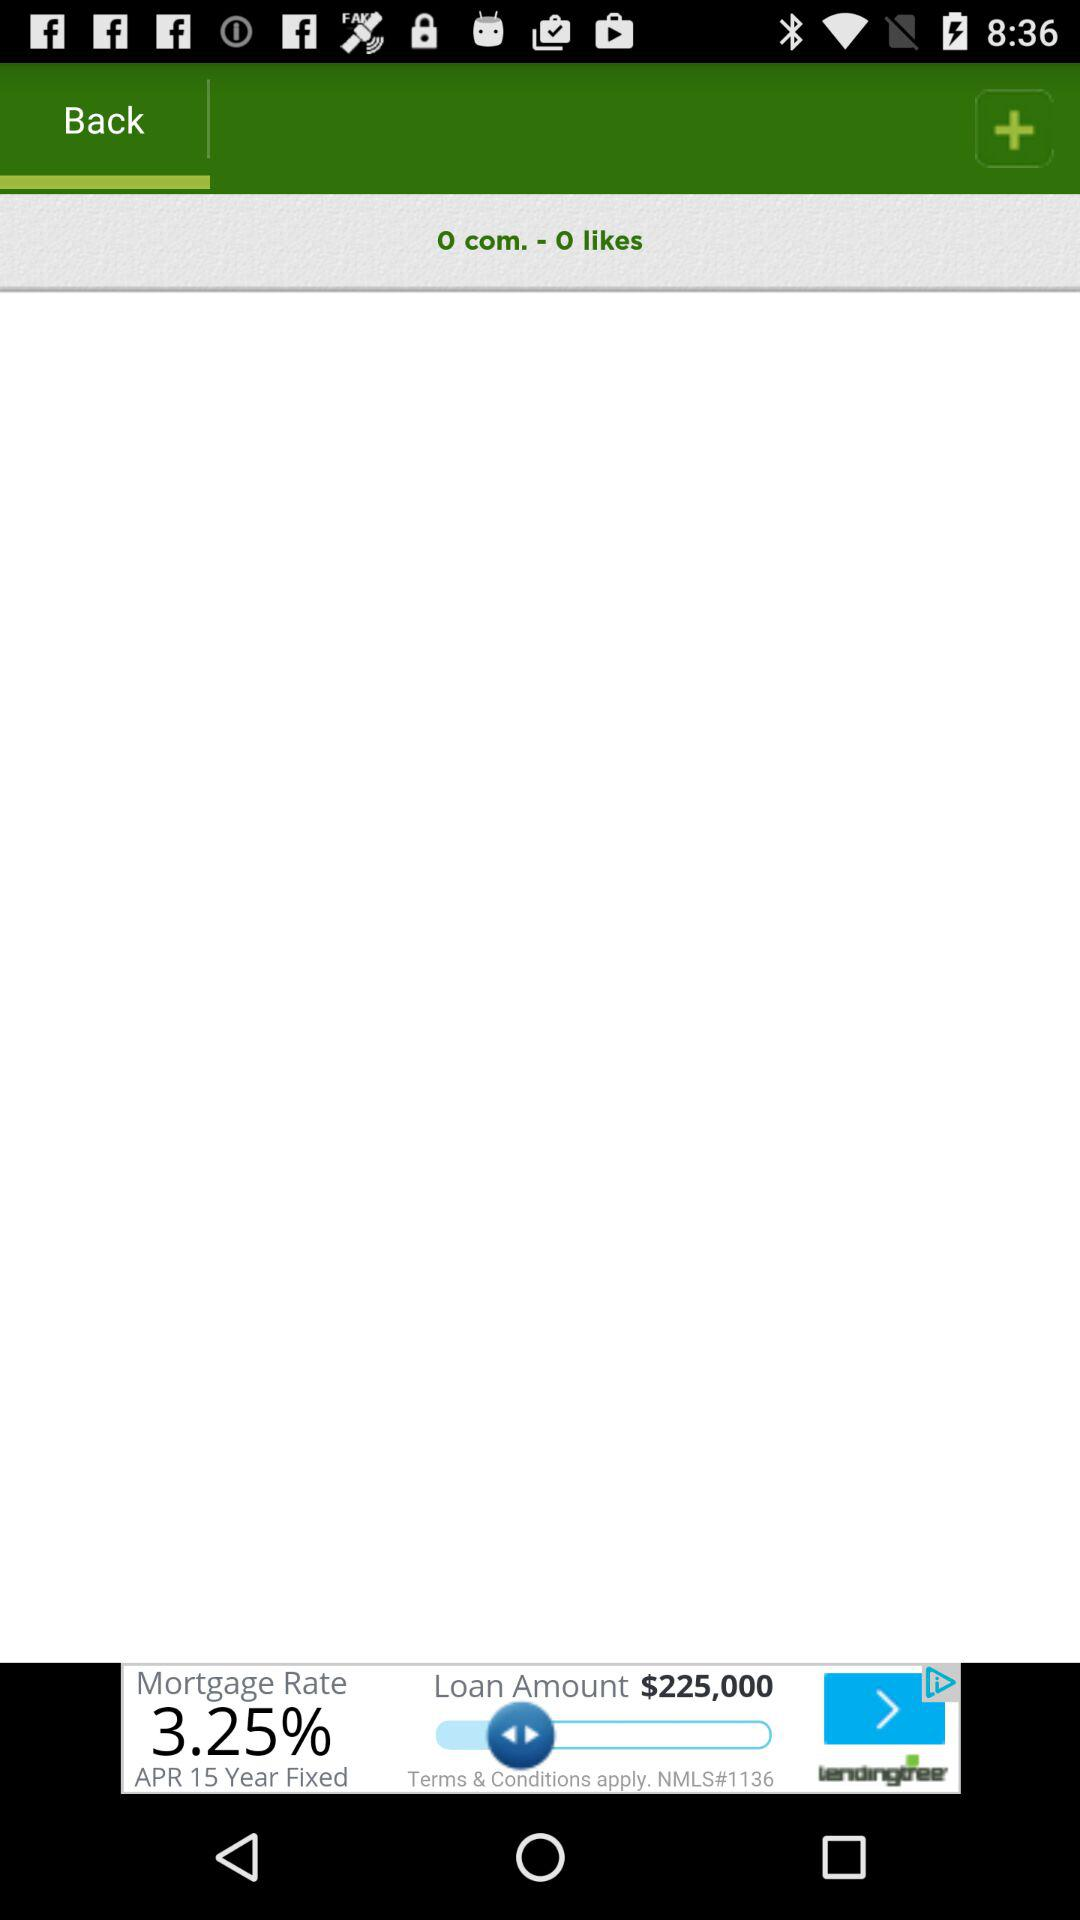How many comments are there? There are zero comments. 